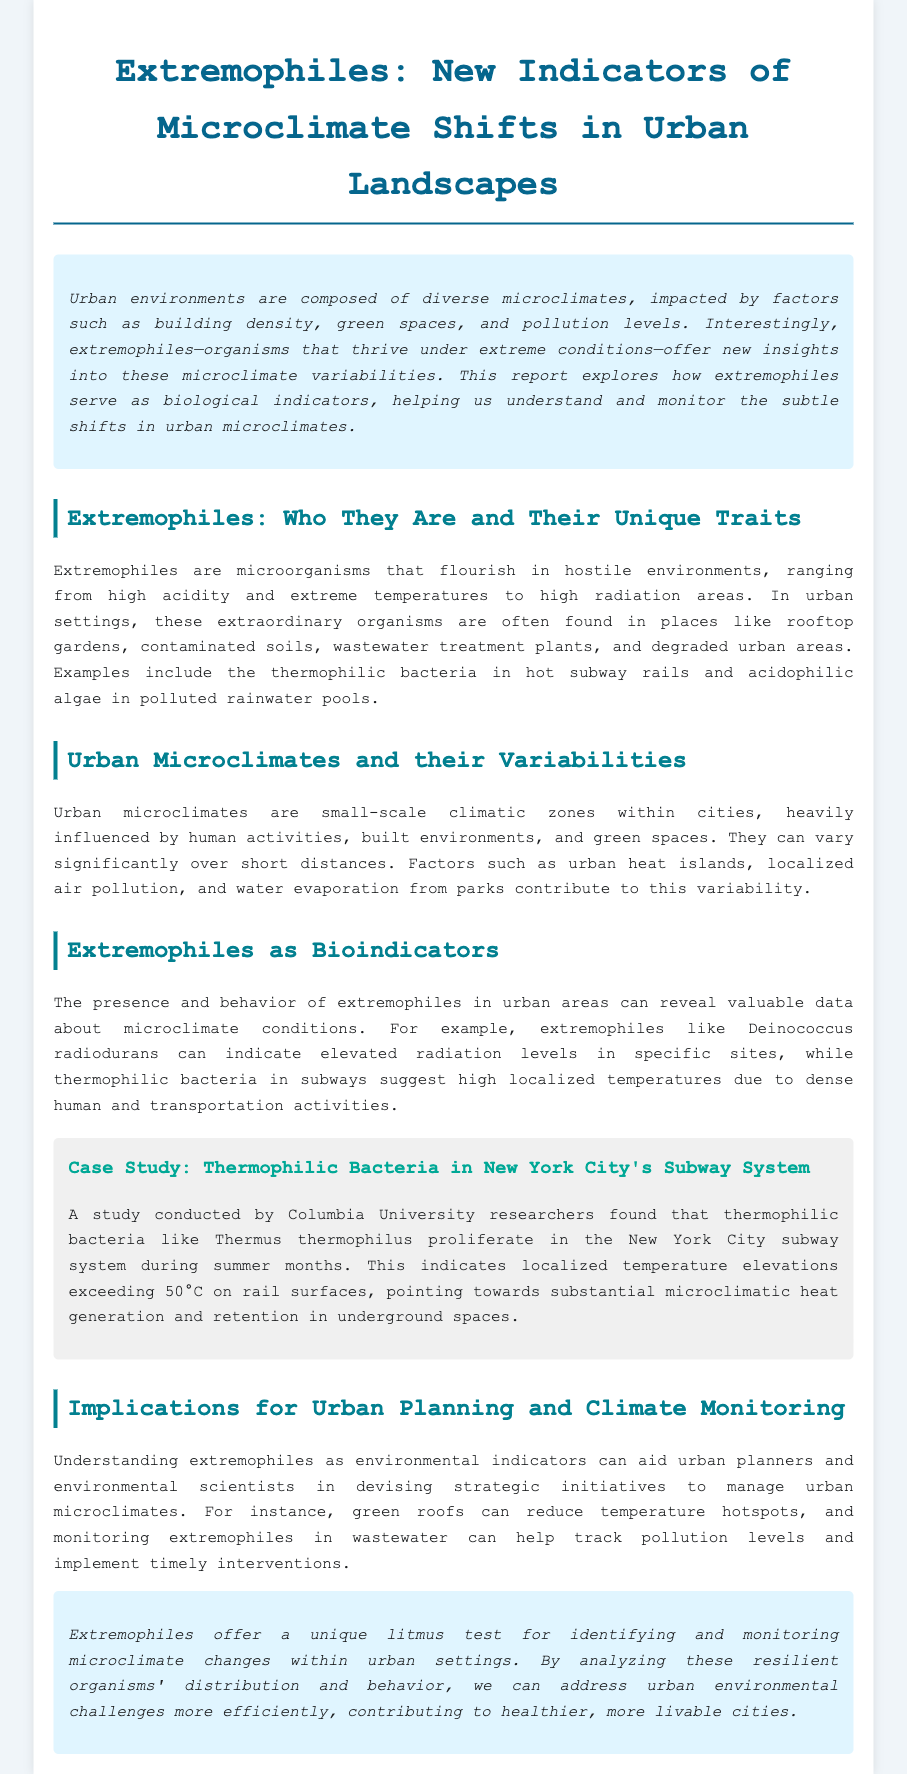What are extremophiles? Extremophiles are microorganisms that flourish in hostile environments.
Answer: Microorganisms Where are extremophiles commonly found in urban areas? Extremophiles are often found in rooftop gardens, contaminated soils, wastewater treatment plants, and degraded urban areas.
Answer: Rooftop gardens What temperature can thermophilic bacteria indicate in subway systems? Thermophilic bacteria like Thermus thermophilus can indicate localized temperature elevations exceeding 50°C.
Answer: 50°C Who conducted the case study on thermophilic bacteria in New York City's subway? The case study was conducted by Columbia University researchers.
Answer: Columbia University What do extremophiles indicate about pollution levels? Monitoring extremophiles in wastewater can help track pollution levels.
Answer: Track pollution levels How can green roofs impact urban microclimates? Green roofs can reduce temperature hotspots.
Answer: Reduce temperature hotspots What are two factors that influence urban microclimates? Urban heat islands and localized air pollution influence urban microclimates.
Answer: Urban heat islands, localized air pollution Which organism indicates elevated radiation levels? Deinococcus radiodurans can indicate elevated radiation levels.
Answer: Deinococcus radiodurans 